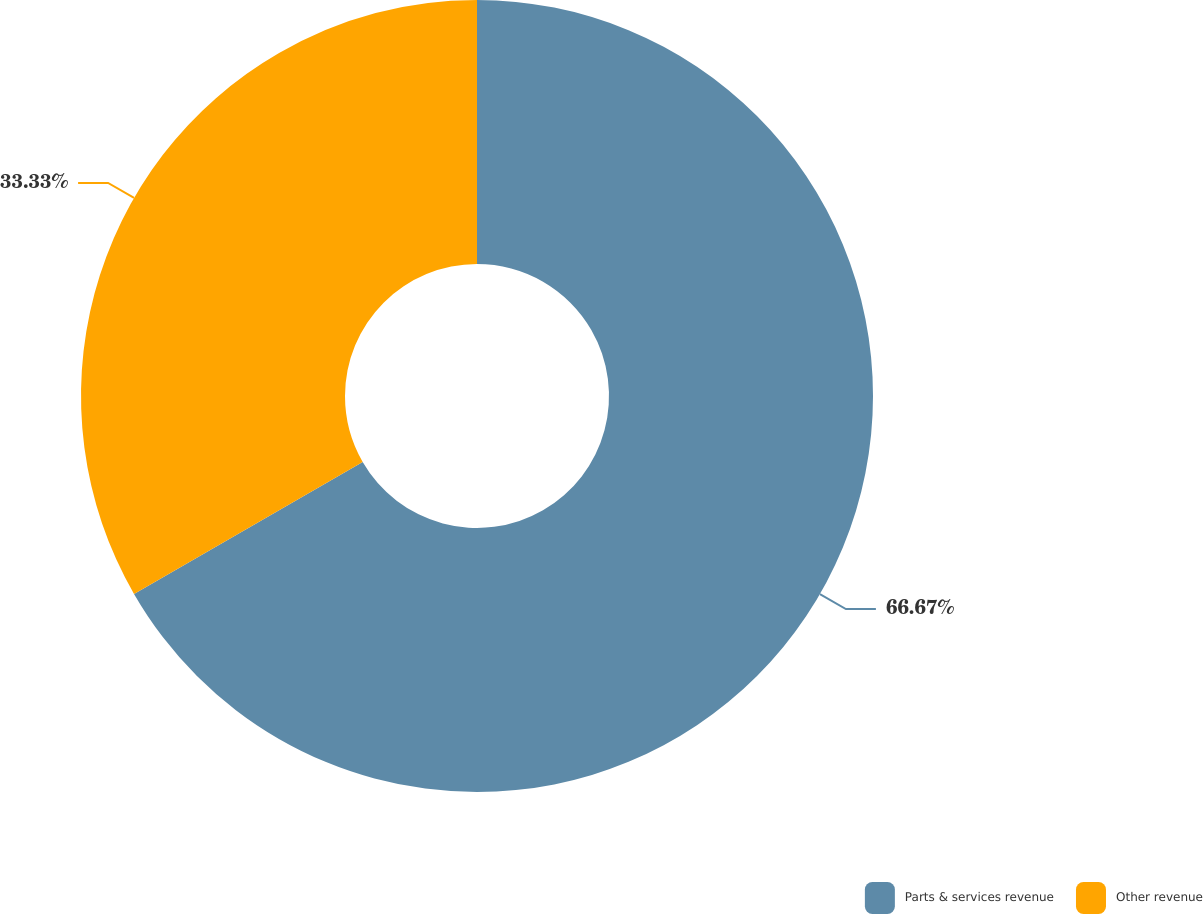<chart> <loc_0><loc_0><loc_500><loc_500><pie_chart><fcel>Parts & services revenue<fcel>Other revenue<nl><fcel>66.67%<fcel>33.33%<nl></chart> 